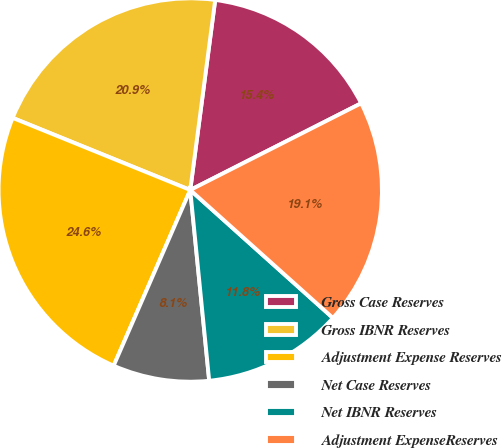Convert chart to OTSL. <chart><loc_0><loc_0><loc_500><loc_500><pie_chart><fcel>Gross Case Reserves<fcel>Gross IBNR Reserves<fcel>Adjustment Expense Reserves<fcel>Net Case Reserves<fcel>Net IBNR Reserves<fcel>Adjustment ExpenseReserves<nl><fcel>15.45%<fcel>20.94%<fcel>24.6%<fcel>8.12%<fcel>11.79%<fcel>19.11%<nl></chart> 